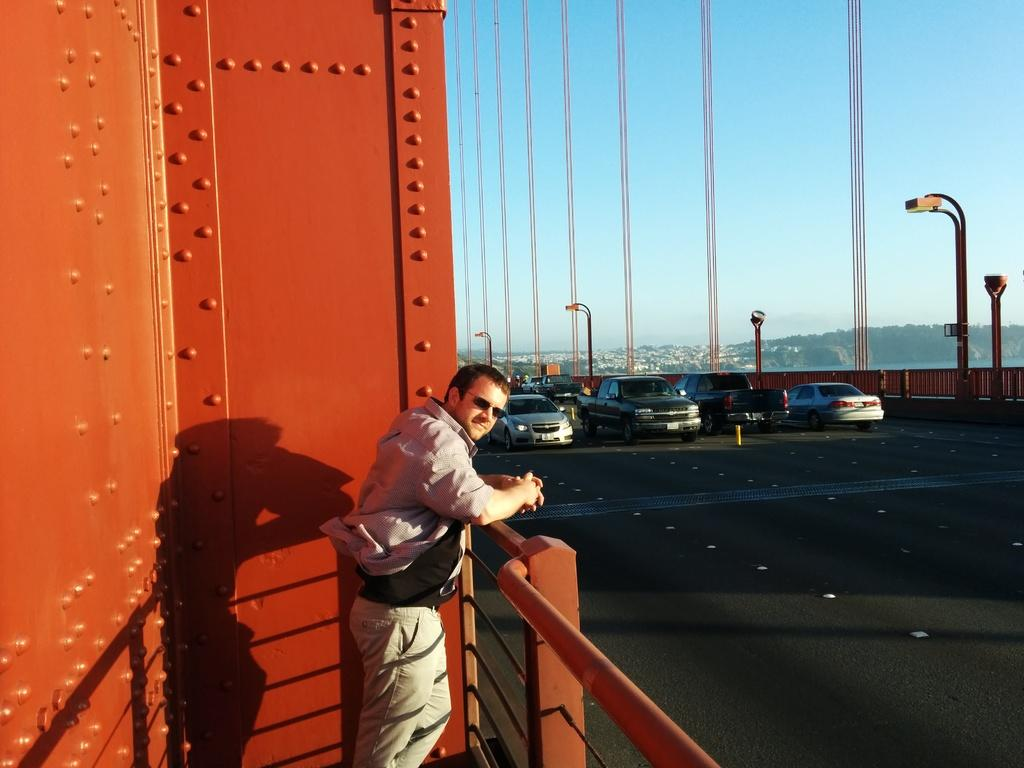What is the man in the image doing? The man is standing on a bridge in the image. What else can be seen on the bridge? There are vehicles on the bridge. What can be seen in the background of the image? There are light poles, trees, and the sky visible in the background. What type of pies can be smelled in the image? There is no mention of pies or any smell in the image, so it cannot be determined from the image. 